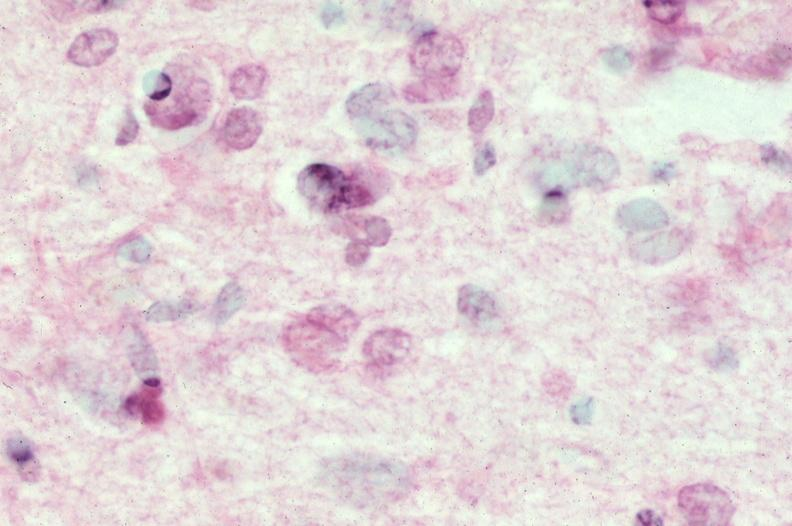does this image show brain, frontal lobe atrophy, pick 's disease?
Answer the question using a single word or phrase. Yes 